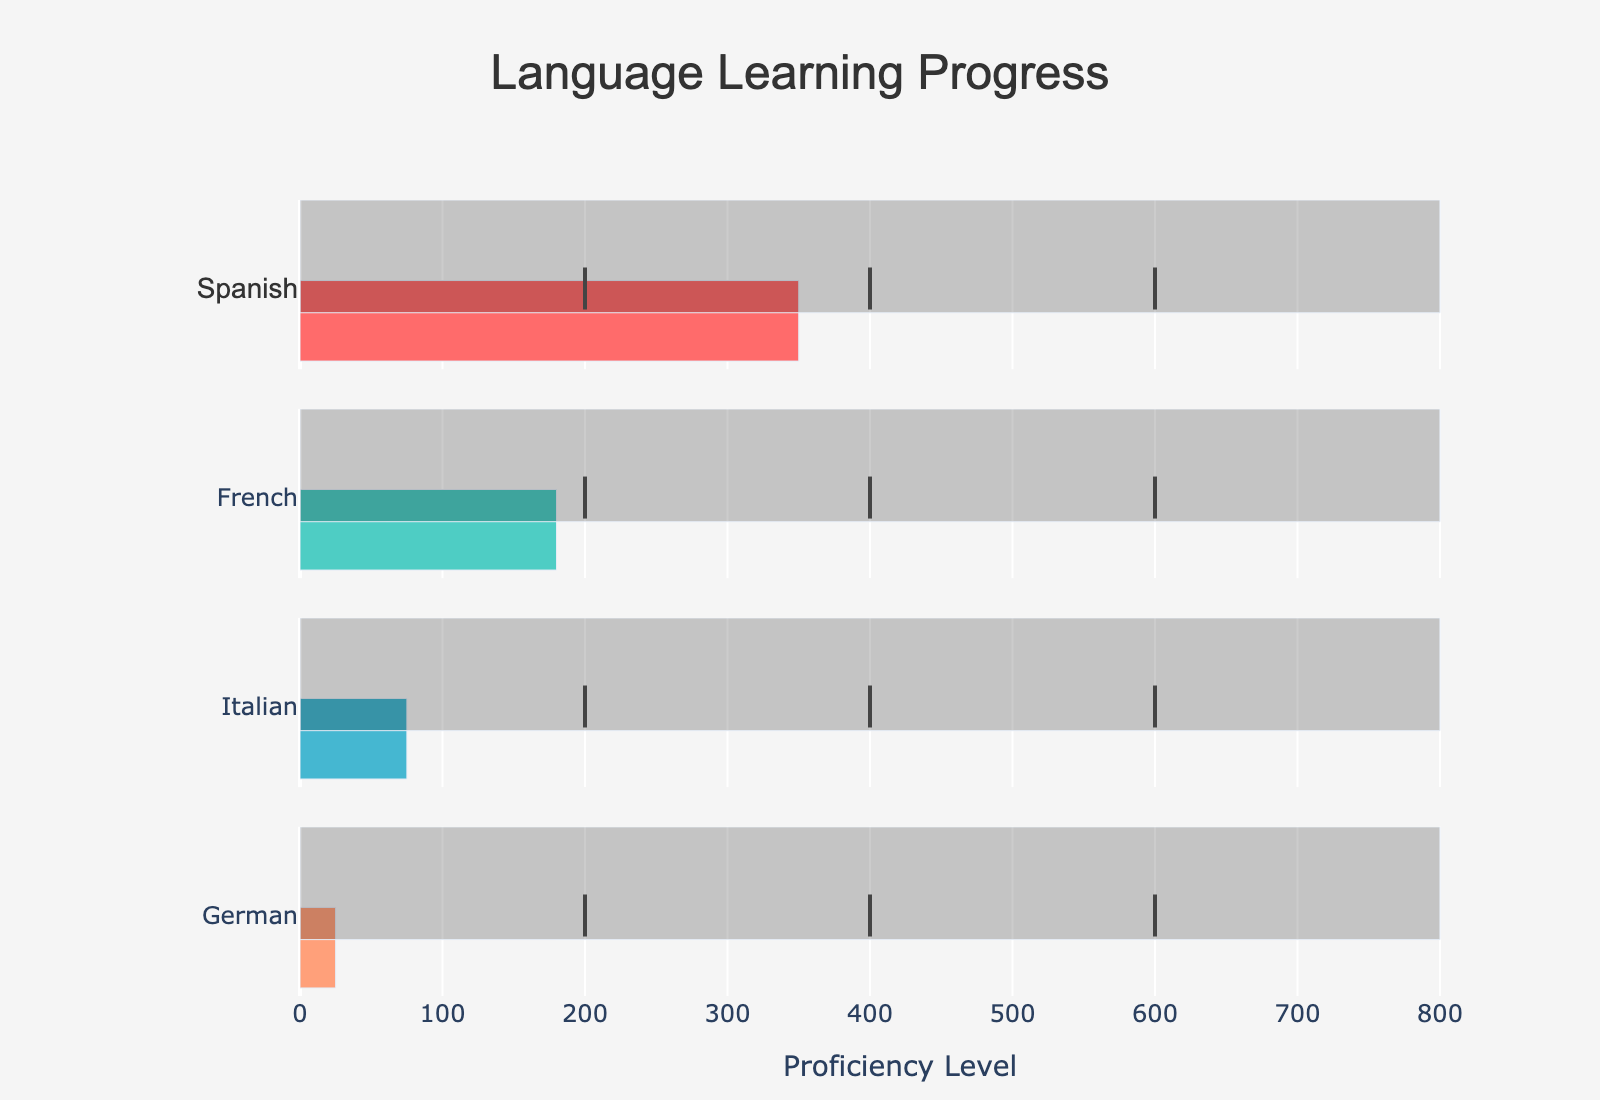How many languages are tracked in this chart? The chart lists four languages: Spanish, French, Italian, and German. This is based on the y-axis labels.
Answer: 4 What is the title of this chart? The title is displayed at the top of the chart. It reads "Language Learning Progress."
Answer: Language Learning Progress What is the proficiency goal for Italian? The Goal bar for Italian shows a value of 800, which means the proficiency goal is 800.
Answer: 800 How far is the current proficiency in French from the Intermediate level? The current proficiency in French is 180. The Intermediate level is marked at 400. So, the distance is 400 - 180 = 220.
Answer: 220 Which language has the highest current proficiency? Among the four languages, the bar with the longest length for current proficiency is Spanish, which stands at 350.
Answer: Spanish What milestone has the Spanish proficiency level surpassed? The current proficiency level for Spanish is 350. It has surpassed the Beginner milestone, which is at 200.
Answer: Beginner Compare the current proficiency of German and Italian. Which one is higher? The current proficiency level for German is 25 and for Italian, it is 75. Comparing these, Italian has a higher proficiency level.
Answer: Italian By how much does the Spanish current proficiency exceed the French current proficiency? The current proficiency for Spanish is 350 and for French, it is 180. The difference is 350 - 180 = 170.
Answer: 170 What is the proficiency level at the Beginner milestone? All four languages have the Beginner milestone marked at 200.
Answer: 200 Which language has the least progression towards its proficiency goal? Observing the bars, German has only reached a proficiency level of 25, while its goal is 800. This is the least progression compared to the other languages.
Answer: German 